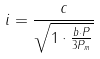<formula> <loc_0><loc_0><loc_500><loc_500>i = \frac { c } { \sqrt { 1 \cdot \frac { b \cdot P } { 3 P _ { m } } } }</formula> 